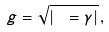<formula> <loc_0><loc_0><loc_500><loc_500>g = \sqrt { | \ = \gamma | } \, ,</formula> 